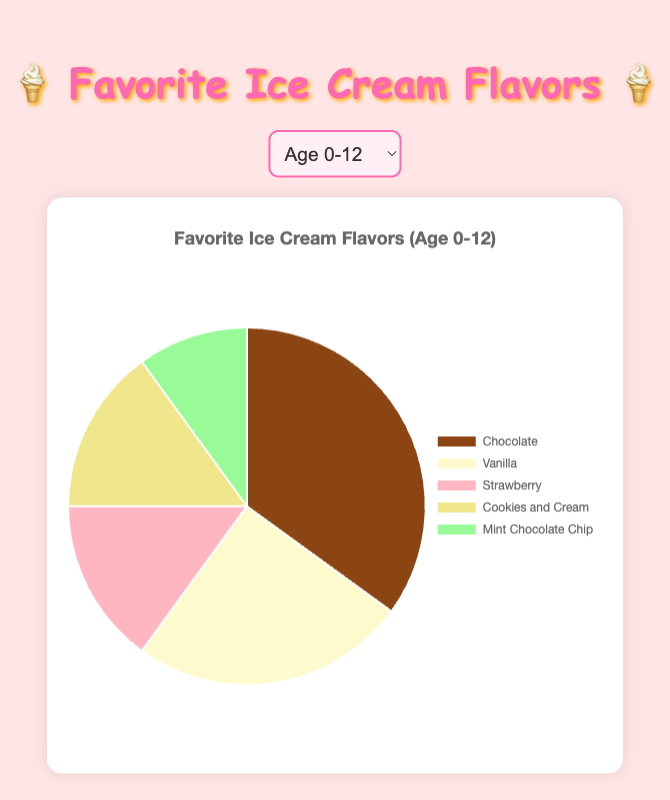Which age group has the highest preference for Chocolate flavor? To answer this, we need to check the pie chart and look at the percentage or angle occupied by the Chocolate section for each age group. The 0-12 age group has the highest preference for Chocolate with 35%.
Answer: 0-12 Which age group has the lowest percentage for Mint Chocolate Chip? We need to find the smallest segment for Mint Chocolate Chip across all age groups. The 60+ and 46-60 age groups both have 5% for Mint Chocolate Chip, which is the lowest.
Answer: 60+, 46-60 (tie) What is the total percentage for Vanilla and Butter Pecan for the age group 60+? We look at the pie chart for the age group 60+ and add the percentages for Vanilla (30%) and Butter Pecan (15%). The total is 30% + 15% = 45%.
Answer: 45% Which ice cream flavor is equally popular in the 19-30 and 31-45 age groups? We need to find a segment that has the same percentage for both age groups. Both age groups have Cookies and Cream at 10%.
Answer: Cookies and Cream How does the popularity of Strawberry change from age group 0-12 to 60+? We compare the Strawberry segments across the age groups. The preference decreases from 15% in the 0-12 age group to 10% in the 60+ age group.
Answer: Decreases by 5% For the age group 13-18, which flavor is preferred more, Vanilla or Cookies and Cream? We compare the size of the Vanilla and Cookies and Cream segments in the 13-18 age group. Cookies and Cream is 25% while Vanilla is 20%.
Answer: Cookies and Cream What is the combined percentage of Strawberry, Cookies and Cream, and Mint Chocolate Chip for the age group 13-18? We sum the percentages for Strawberry (10%), Cookies and Cream (25%), and Mint Chocolate Chip (15%). The total is 10% + 25% + 15% = 50%.
Answer: 50% Which flavors are equally popular in the 46-60 age group? We need to identify segments with the same percentage for the 46-60 age group. Rocky Road and Pistachio both have 5%.
Answer: Rocky Road, Pistachio What is the average percentage of Chocolate across all age groups? First, we add the percentages for Chocolate across all age groups (35% + 30% + 25% + 20% + 25% + 20%). The total is 155%. Since there are 6 age groups, we divide 155% by 6, yielding an average of approximately 25.83%.
Answer: 25.83% Which age group shows the most variety in ice cream preferences based on the number of different flavors? We count the number of unique segments in each pie chart. The 19-30 age group shows the most variety with 8 different flavors.
Answer: 19-30 